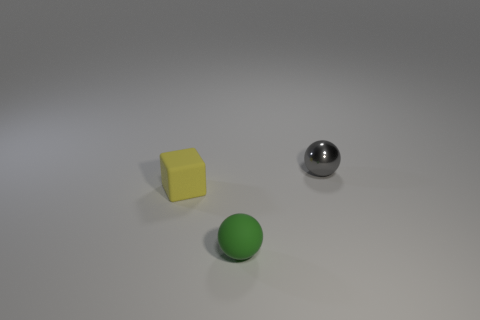What number of cylinders are metallic objects or tiny yellow rubber objects?
Offer a very short reply. 0. There is a small ball behind the sphere that is in front of the tiny gray thing; what number of small yellow objects are right of it?
Ensure brevity in your answer.  0. There is another thing that is the same shape as the green rubber thing; what is its material?
Provide a short and direct response. Metal. Are there any other things that have the same material as the tiny green thing?
Provide a short and direct response. Yes. There is a small ball in front of the small gray sphere; what is its color?
Your response must be concise. Green. Are the gray object and the ball that is in front of the cube made of the same material?
Ensure brevity in your answer.  No. What is the material of the gray thing?
Provide a succinct answer. Metal. The other object that is the same material as the tiny green thing is what shape?
Your response must be concise. Cube. How many other objects are there of the same shape as the tiny green rubber thing?
Make the answer very short. 1. There is a green matte object; what number of metallic spheres are behind it?
Keep it short and to the point. 1. 